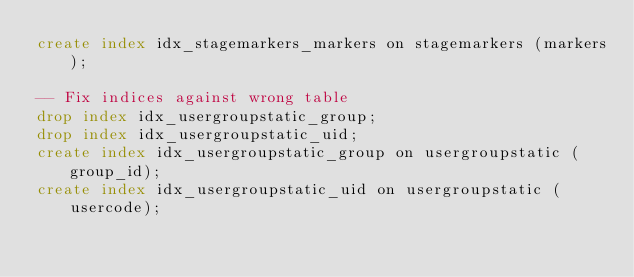Convert code to text. <code><loc_0><loc_0><loc_500><loc_500><_SQL_>create index idx_stagemarkers_markers on stagemarkers (markers);

-- Fix indices against wrong table
drop index idx_usergroupstatic_group;
drop index idx_usergroupstatic_uid;
create index idx_usergroupstatic_group on usergroupstatic (group_id);
create index idx_usergroupstatic_uid on usergroupstatic (usercode);</code> 